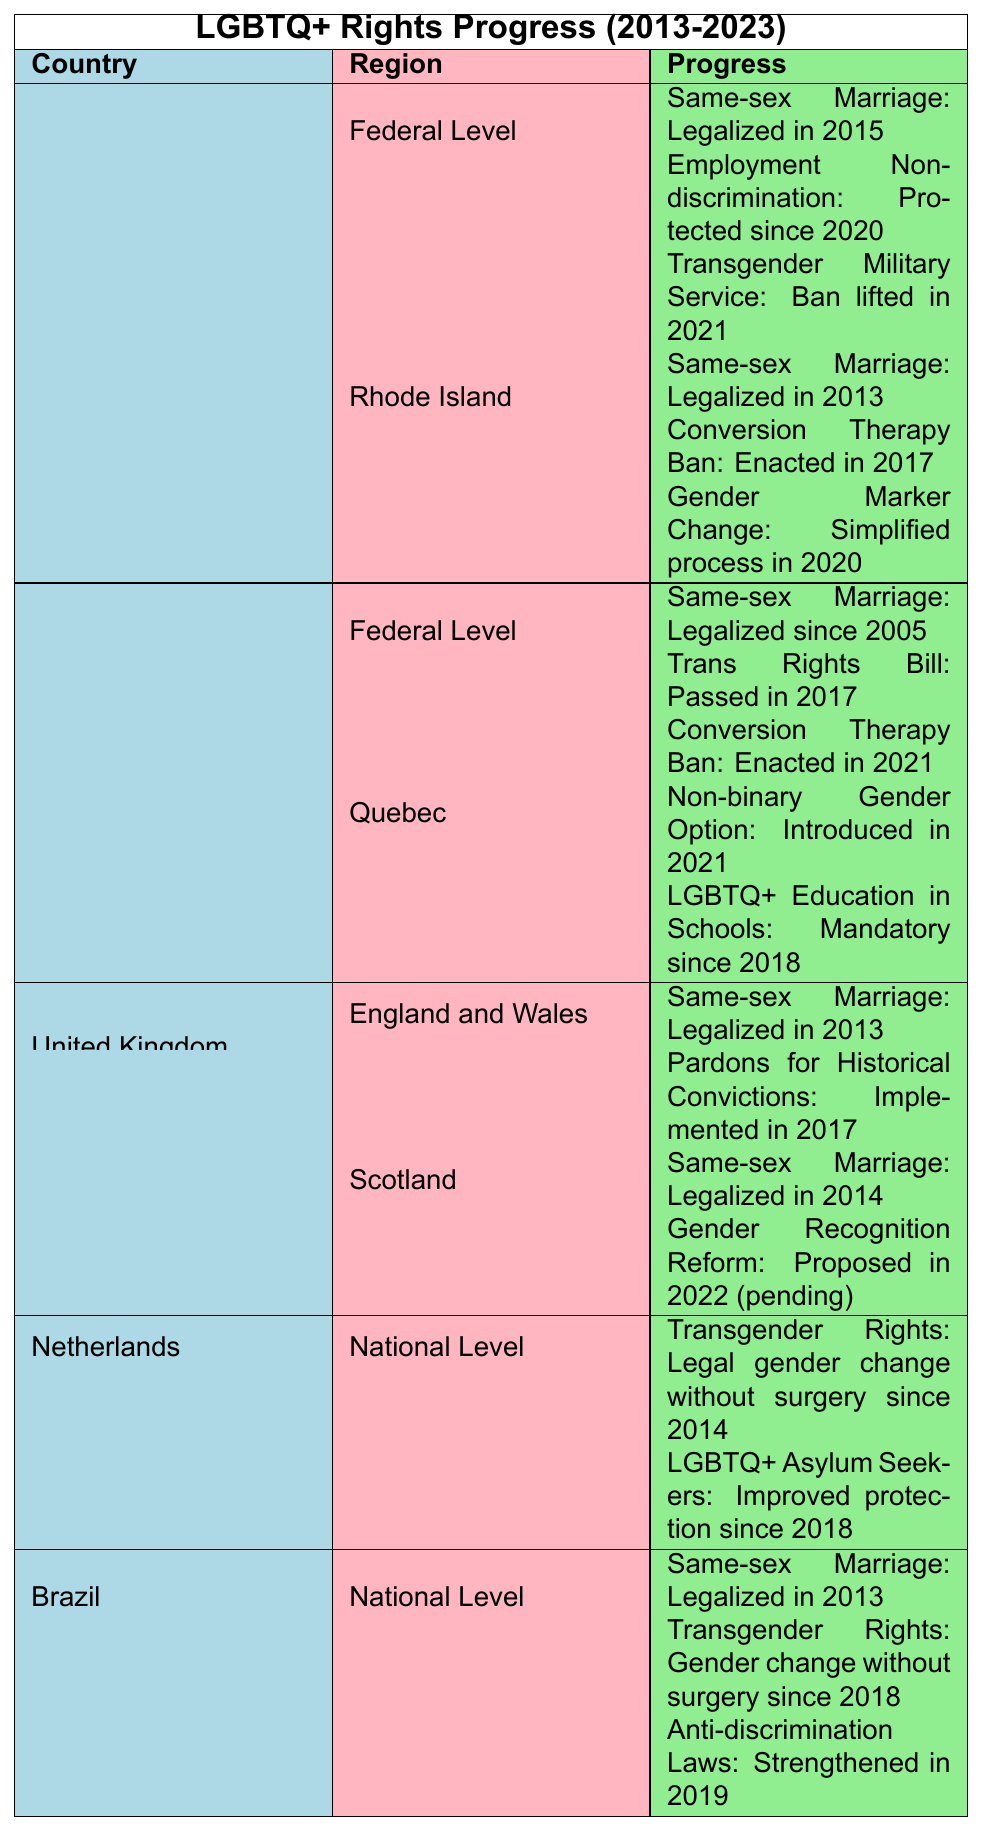What year was same-sex marriage legalized in the United States? The table states that same-sex marriage was legalized at the federal level in the United States in 2015.
Answer: 2015 What significant LGBTQ+ rights legislation did Canada pass in 2017? The table lists that Canada passed the Trans Rights Bill in 2017.
Answer: Trans Rights Bill Is conversion therapy banned in Rhode Island? The information in the table indicates that Rhode Island enacted a conversion therapy ban in 2017, which confirms that it is banned.
Answer: Yes How many significant changes happened for LGBTQ+ rights in the United States by 2021? The table details three significant changes at the federal level: legalization of same-sex marriage in 2015, employment non-discrimination protections in 2020, and lifting the transgender military service ban in 2021.
Answer: 3 What is the newest LGBTQ+ rights legislation in Canada according to the table? The latest legislation mentioned for Canada is the Conversion Therapy Ban enacted in 2021, which is the most recent change.
Answer: Conversion Therapy Ban in 2021 How does the LGBTQ+ rights progress compare between Rhode Island and Canada? The table shows that both Rhode Island and Canada have made progress in LGBTQ+ rights, but since 2005, Canada has had legal same-sex marriage, while Rhode Island legalized it in 2013. Additionally, Canada has passed a Trans Rights Bill and a Conversion Therapy Ban more recently than Rhode Island. Thus, Canada has a broader and earlier range of protections.
Answer: Canada has broader and earlier protections Which country legalized same-sex marriage first: the United States or Brazil? The table indicates that Brazil legalized same-sex marriage in 2013, while the U.S. did so in 2015, indicating Brazil was first.
Answer: Brazil What are the differences in LGBTQ+ rights progress between Canada and the United Kingdom? The table indicates Canada has legalized same-sex marriage since 2005 and has enacted several laws in the past decade, including a Trans Rights Bill in 2017. The UK legalized same-sex marriage in 2013 (England and Wales) and had pardons for historical convictions in 2017 but proposes a gender recognition reform in Scotland that is still pending. Canada has more established and comprehensive protections compared to the UK.
Answer: Canada has more comprehensive progress than the UK Are there any specific LGBTQ+ rights for non-binary individuals in Canada? The table states that Quebec introduced a non-binary gender option in 2021, reflecting specific rights for non-binary individuals.
Answer: Yes, a non-binary gender option introduced in 2021 What key LGBTQ+ rights development occurred in the Netherlands since 2014? The table specifies that the Netherlands allowed legal gender change for transgender individuals without surgery since 2014, marking a significant development in LGBTQ+ rights.
Answer: Legal gender change without surgery since 2014 What LGBTQ+ rights progress has Brazil made since 2013? According to the table, Brazil legalized same-sex marriage in 2013, allowed gender change without surgery since 2018, and strengthened anti-discrimination laws in 2019. These three actions mark significant progress for LGBTQ+ rights in Brazil.
Answer: Three key changes: same-sex marriage, gender change without surgery, stronger anti-discrimination laws 